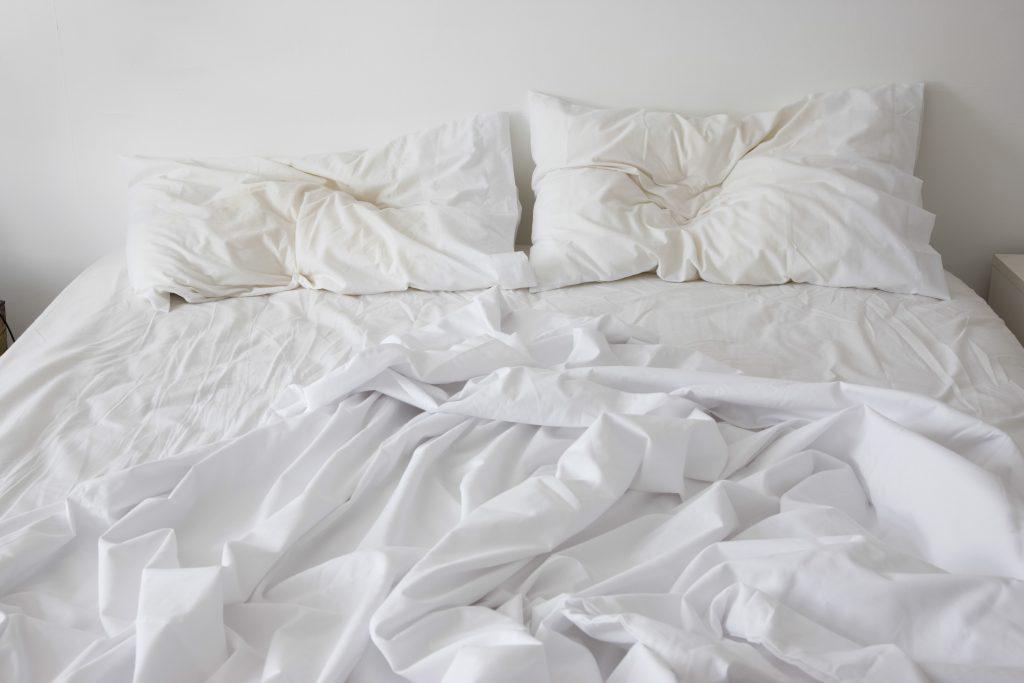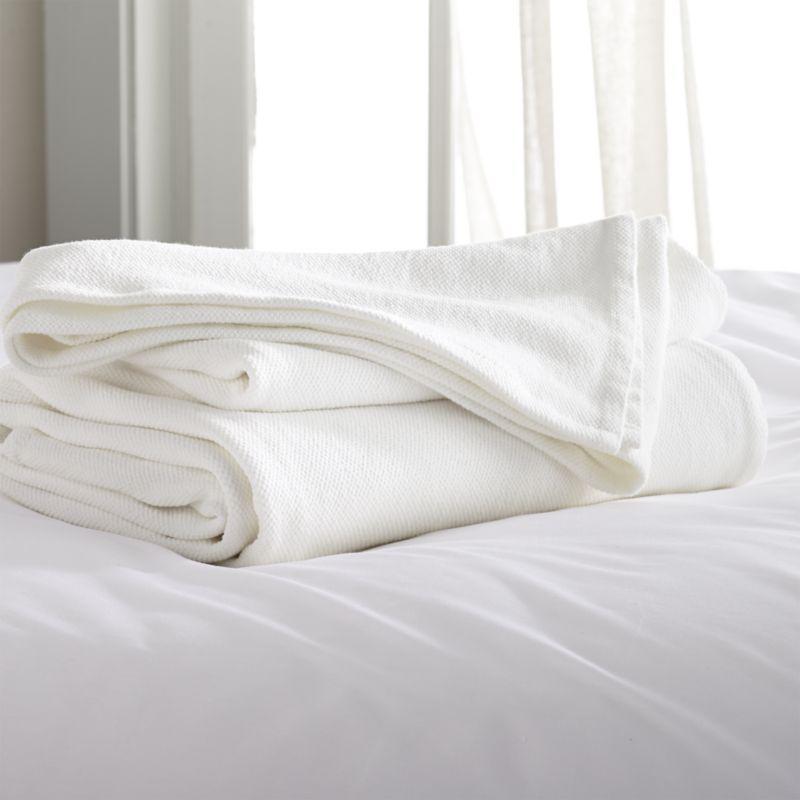The first image is the image on the left, the second image is the image on the right. Considering the images on both sides, is "Rumpled sheets and pillows of an unmade bed are shown in one image." valid? Answer yes or no. Yes. 